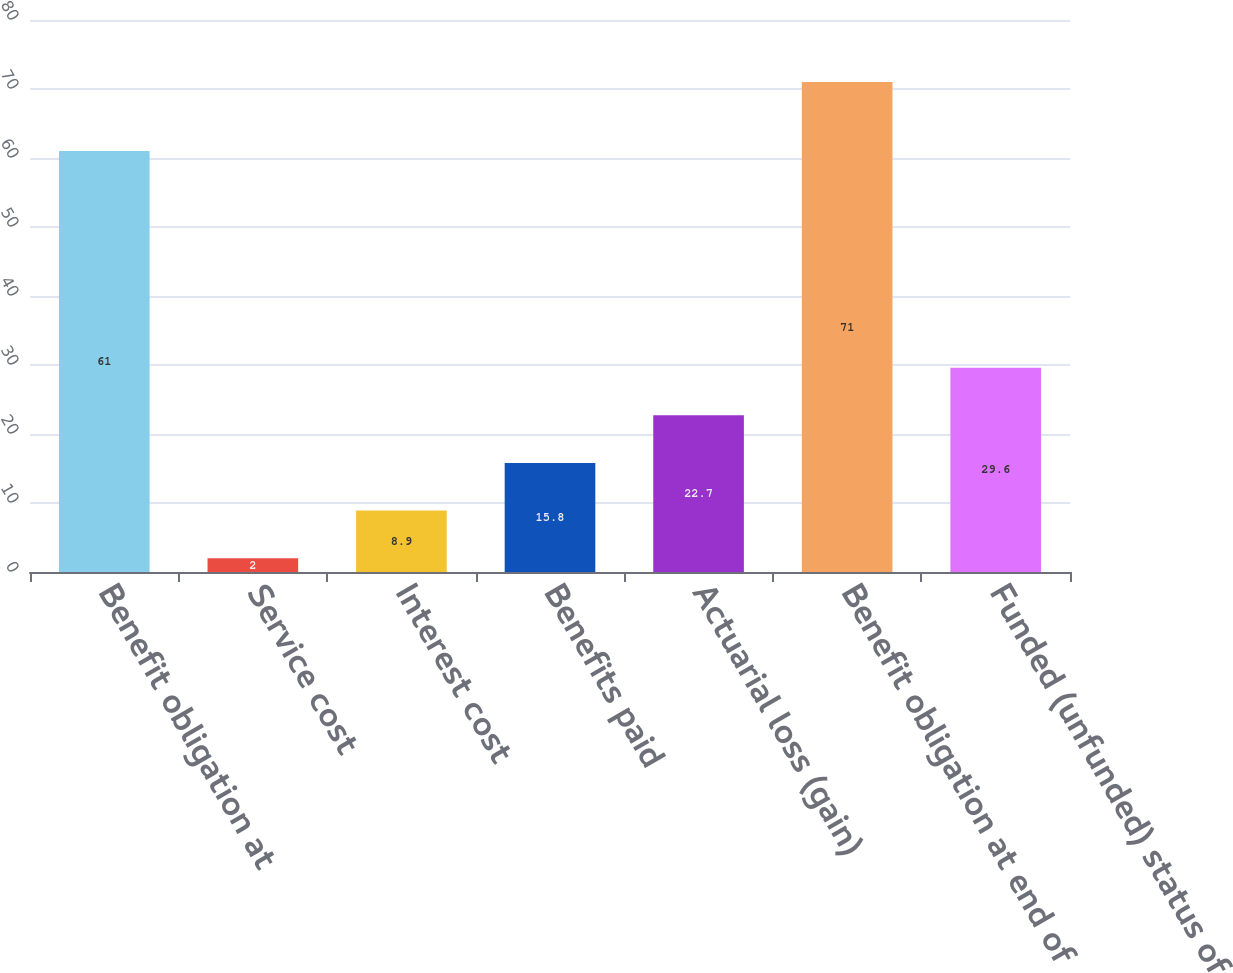Convert chart. <chart><loc_0><loc_0><loc_500><loc_500><bar_chart><fcel>Benefit obligation at<fcel>Service cost<fcel>Interest cost<fcel>Benefits paid<fcel>Actuarial loss (gain)<fcel>Benefit obligation at end of<fcel>Funded (unfunded) status of<nl><fcel>61<fcel>2<fcel>8.9<fcel>15.8<fcel>22.7<fcel>71<fcel>29.6<nl></chart> 